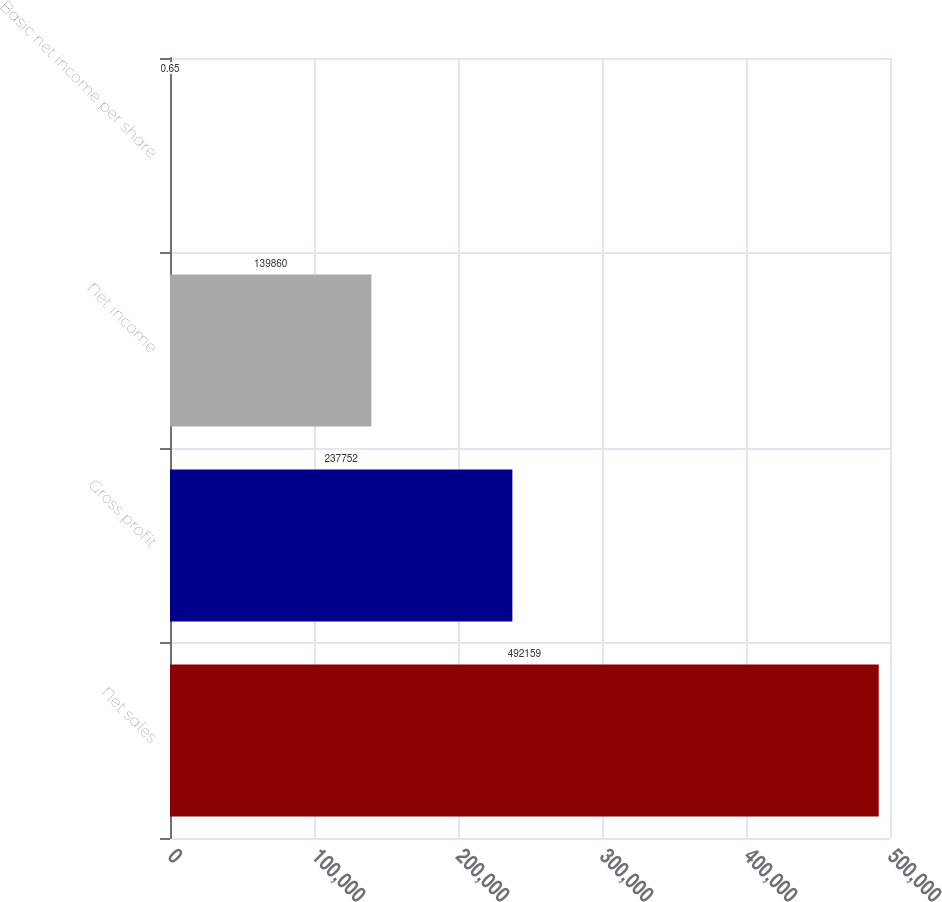<chart> <loc_0><loc_0><loc_500><loc_500><bar_chart><fcel>Net sales<fcel>Gross profit<fcel>Net income<fcel>Basic net income per share<nl><fcel>492159<fcel>237752<fcel>139860<fcel>0.65<nl></chart> 